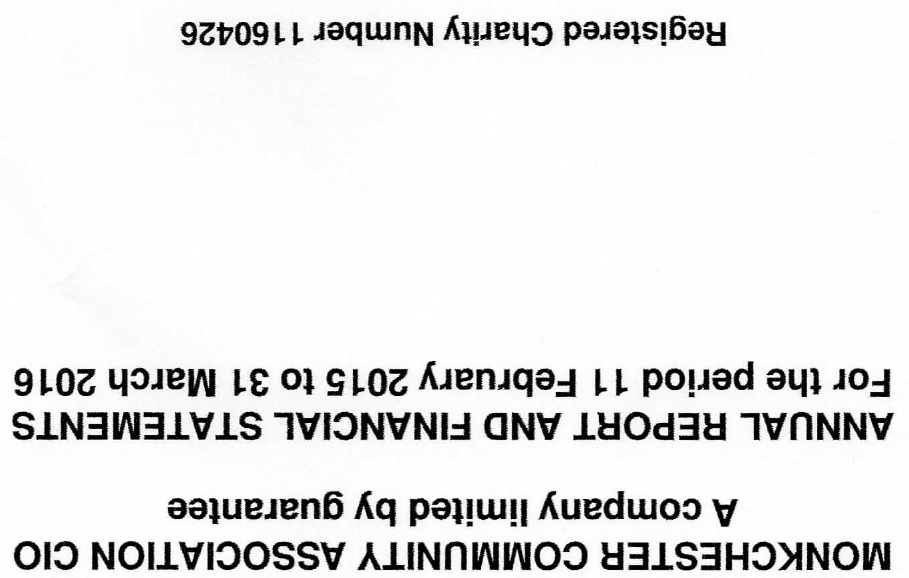What is the value for the address__postcode?
Answer the question using a single word or phrase. NE6 2LJ 